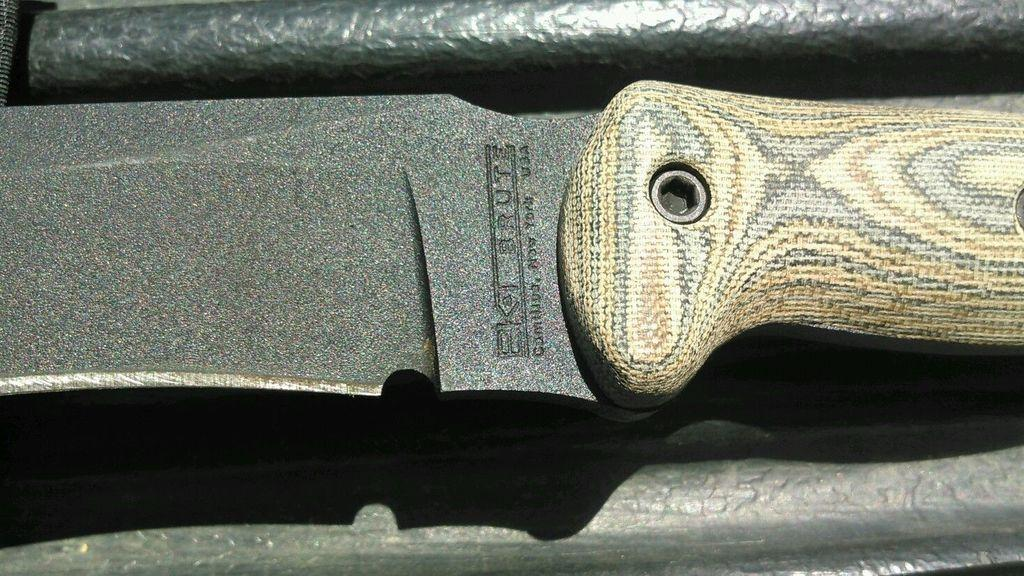What type of object is present on the table in the image? There is a knife in the image. Can you describe the knife in more detail? The knife has a sharp blade and a handle. Where is the knife located in the image? The knife is present on a table. How does the mist affect the street in the image? There is no mist or street present in the image; it only features a knife on a table. 